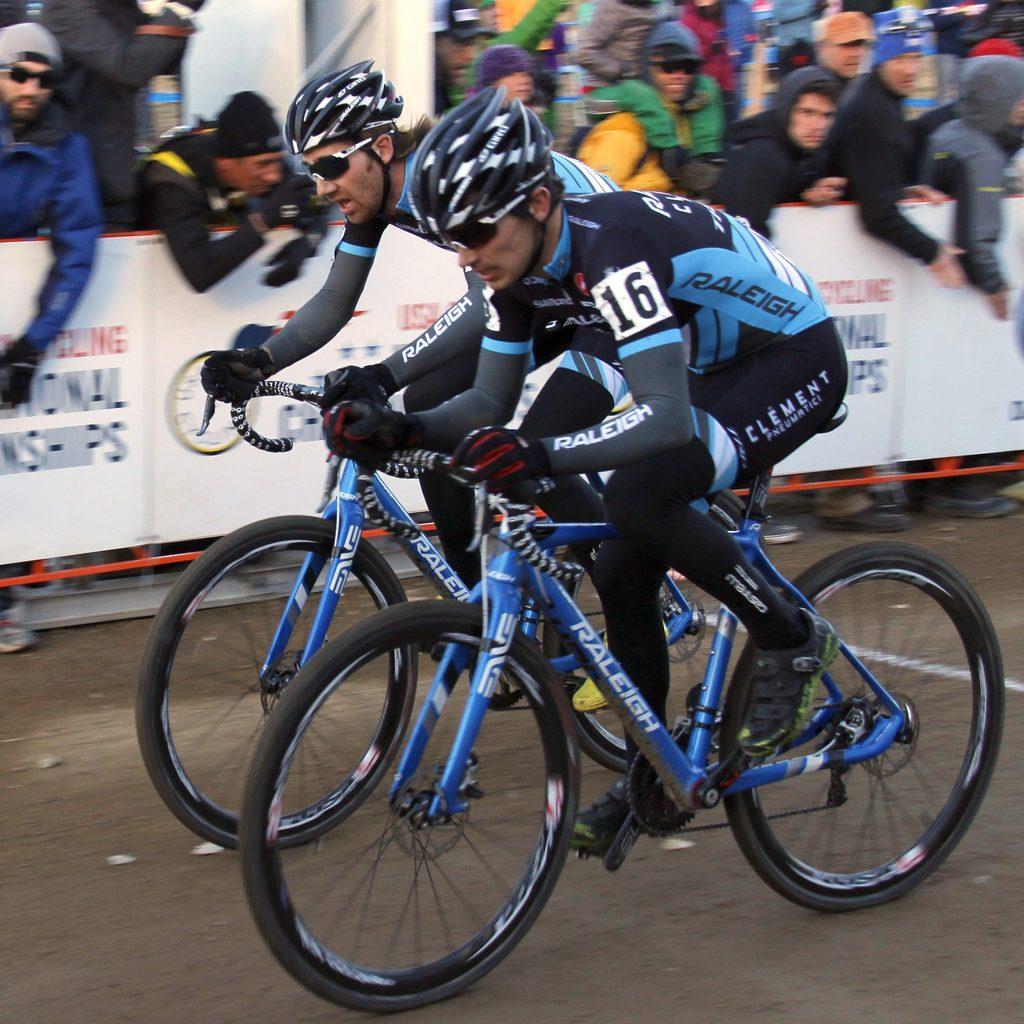In one or two sentences, can you explain what this image depicts? There are two persons wearing helmets and gloves is wearing cycles. In the back there are banners. Also there are many people. Some are wearing caps and goggles. 